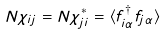Convert formula to latex. <formula><loc_0><loc_0><loc_500><loc_500>N \chi _ { i j } = N \chi _ { j i } ^ { * } = \langle f _ { i \alpha } ^ { \dagger } f _ { j \alpha } \rangle</formula> 